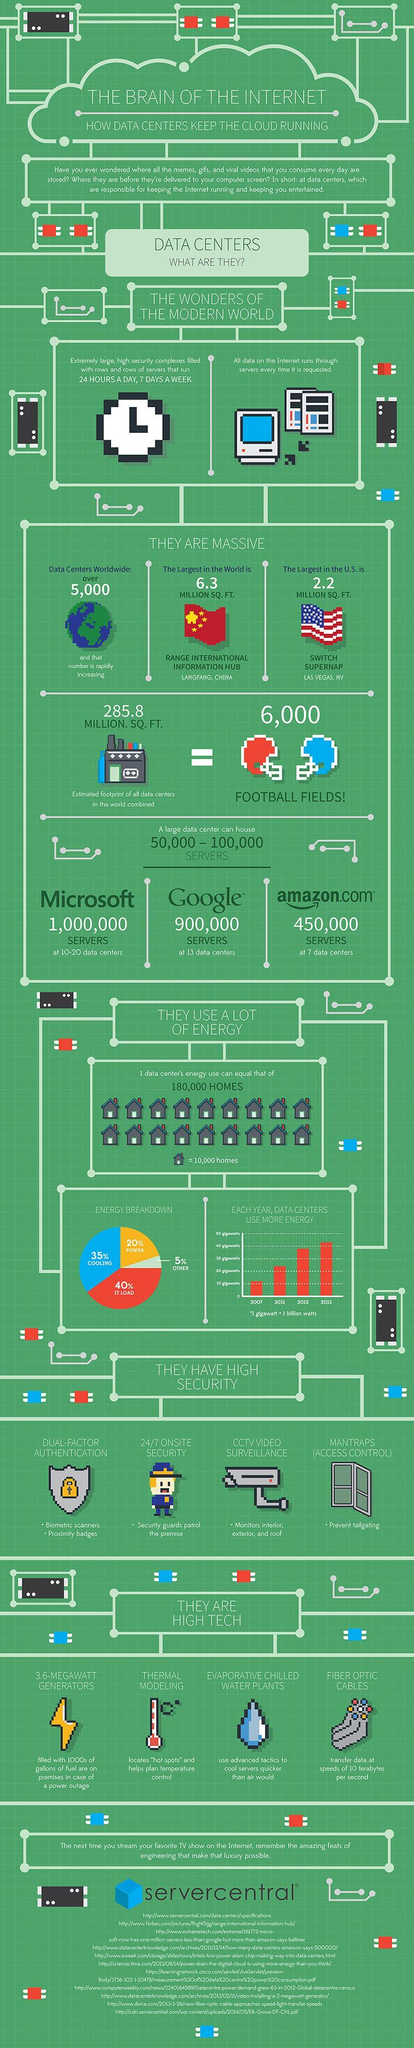In which year did data centers use energy above 40 gigawatts?
Answer the question with a short phrase. 2013 What percent of energy breakdown does cooling and power consume? 55% How many homes does the single house icon represent? 10,000 What requires more energy consumption? IT LOAD How many sources are listed at the bottom? 11 